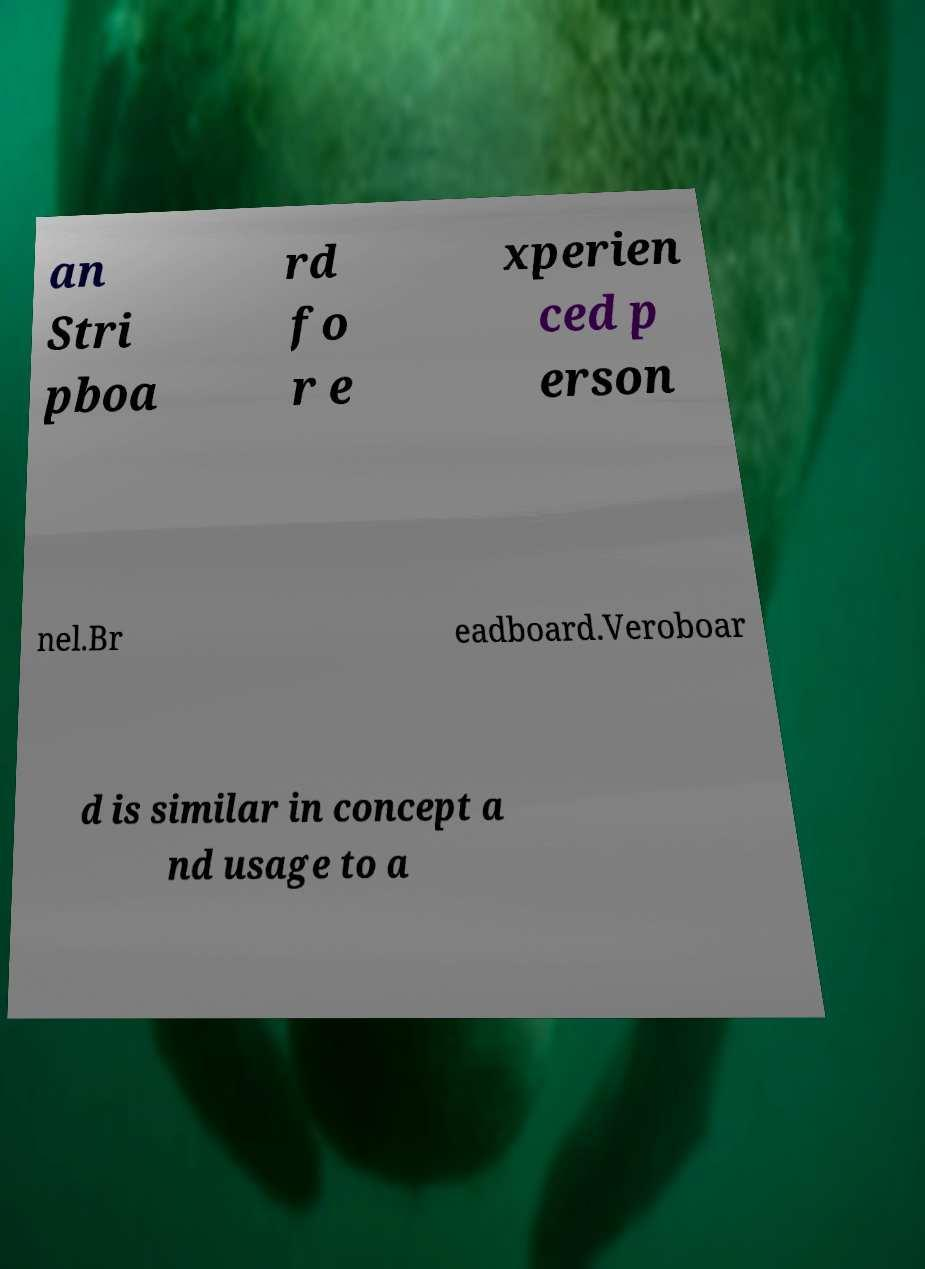Can you accurately transcribe the text from the provided image for me? an Stri pboa rd fo r e xperien ced p erson nel.Br eadboard.Veroboar d is similar in concept a nd usage to a 